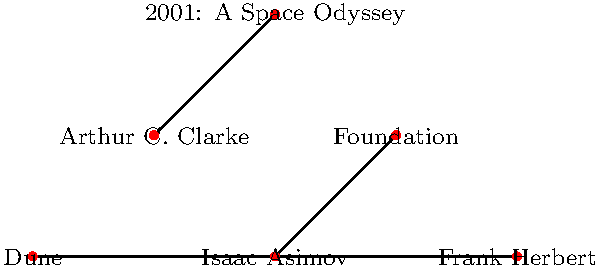In the network diagram above, which sci-fi author is not connected to their most famous work? To answer this question, we need to analyze the connections in the network diagram:

1. Isaac Asimov is connected to "Foundation"
2. Arthur C. Clarke is connected to "2001: A Space Odyssey"
3. Frank Herbert is connected to "Dune"

The diagram shows three pairs of nodes, each representing an author and a famous work. To determine which author is not connected to their most famous work, we need to examine each pair:

1. Isaac Asimov and "Foundation" are directly connected by a line, indicating a correct pairing.
2. Arthur C. Clarke and "2001: A Space Odyssey" are directly connected by a line, indicating a correct pairing.
3. Frank Herbert and "Dune" are directly connected by a line, indicating a correct pairing.

After examining all pairs, we can see that all authors are correctly connected to their most famous works. Therefore, there is no author in this diagram who is not connected to their most famous work.
Answer: None 